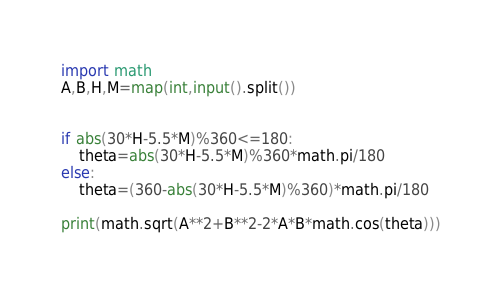<code> <loc_0><loc_0><loc_500><loc_500><_Python_>import math
A,B,H,M=map(int,input().split())


if abs(30*H-5.5*M)%360<=180:
    theta=abs(30*H-5.5*M)%360*math.pi/180
else:
    theta=(360-abs(30*H-5.5*M)%360)*math.pi/180

print(math.sqrt(A**2+B**2-2*A*B*math.cos(theta)))</code> 